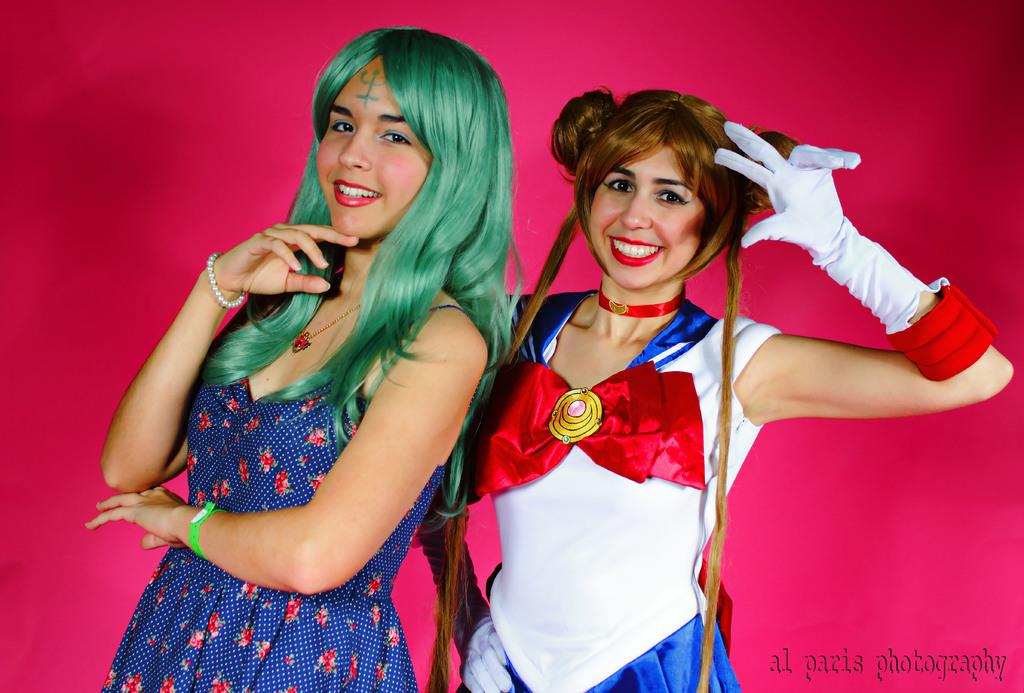How many women are present in the image? There are two women in the image. What can be observed about their clothing? The women are wearing different dresses. Can you describe any accessories that one of the women is wearing? One of the women is wearing gloves. What type of bell can be heard ringing in the image? There is no bell or ringing sound present in the image. What statement is being made by the women in the image? The image does not provide any information about a statement being made by the women. 